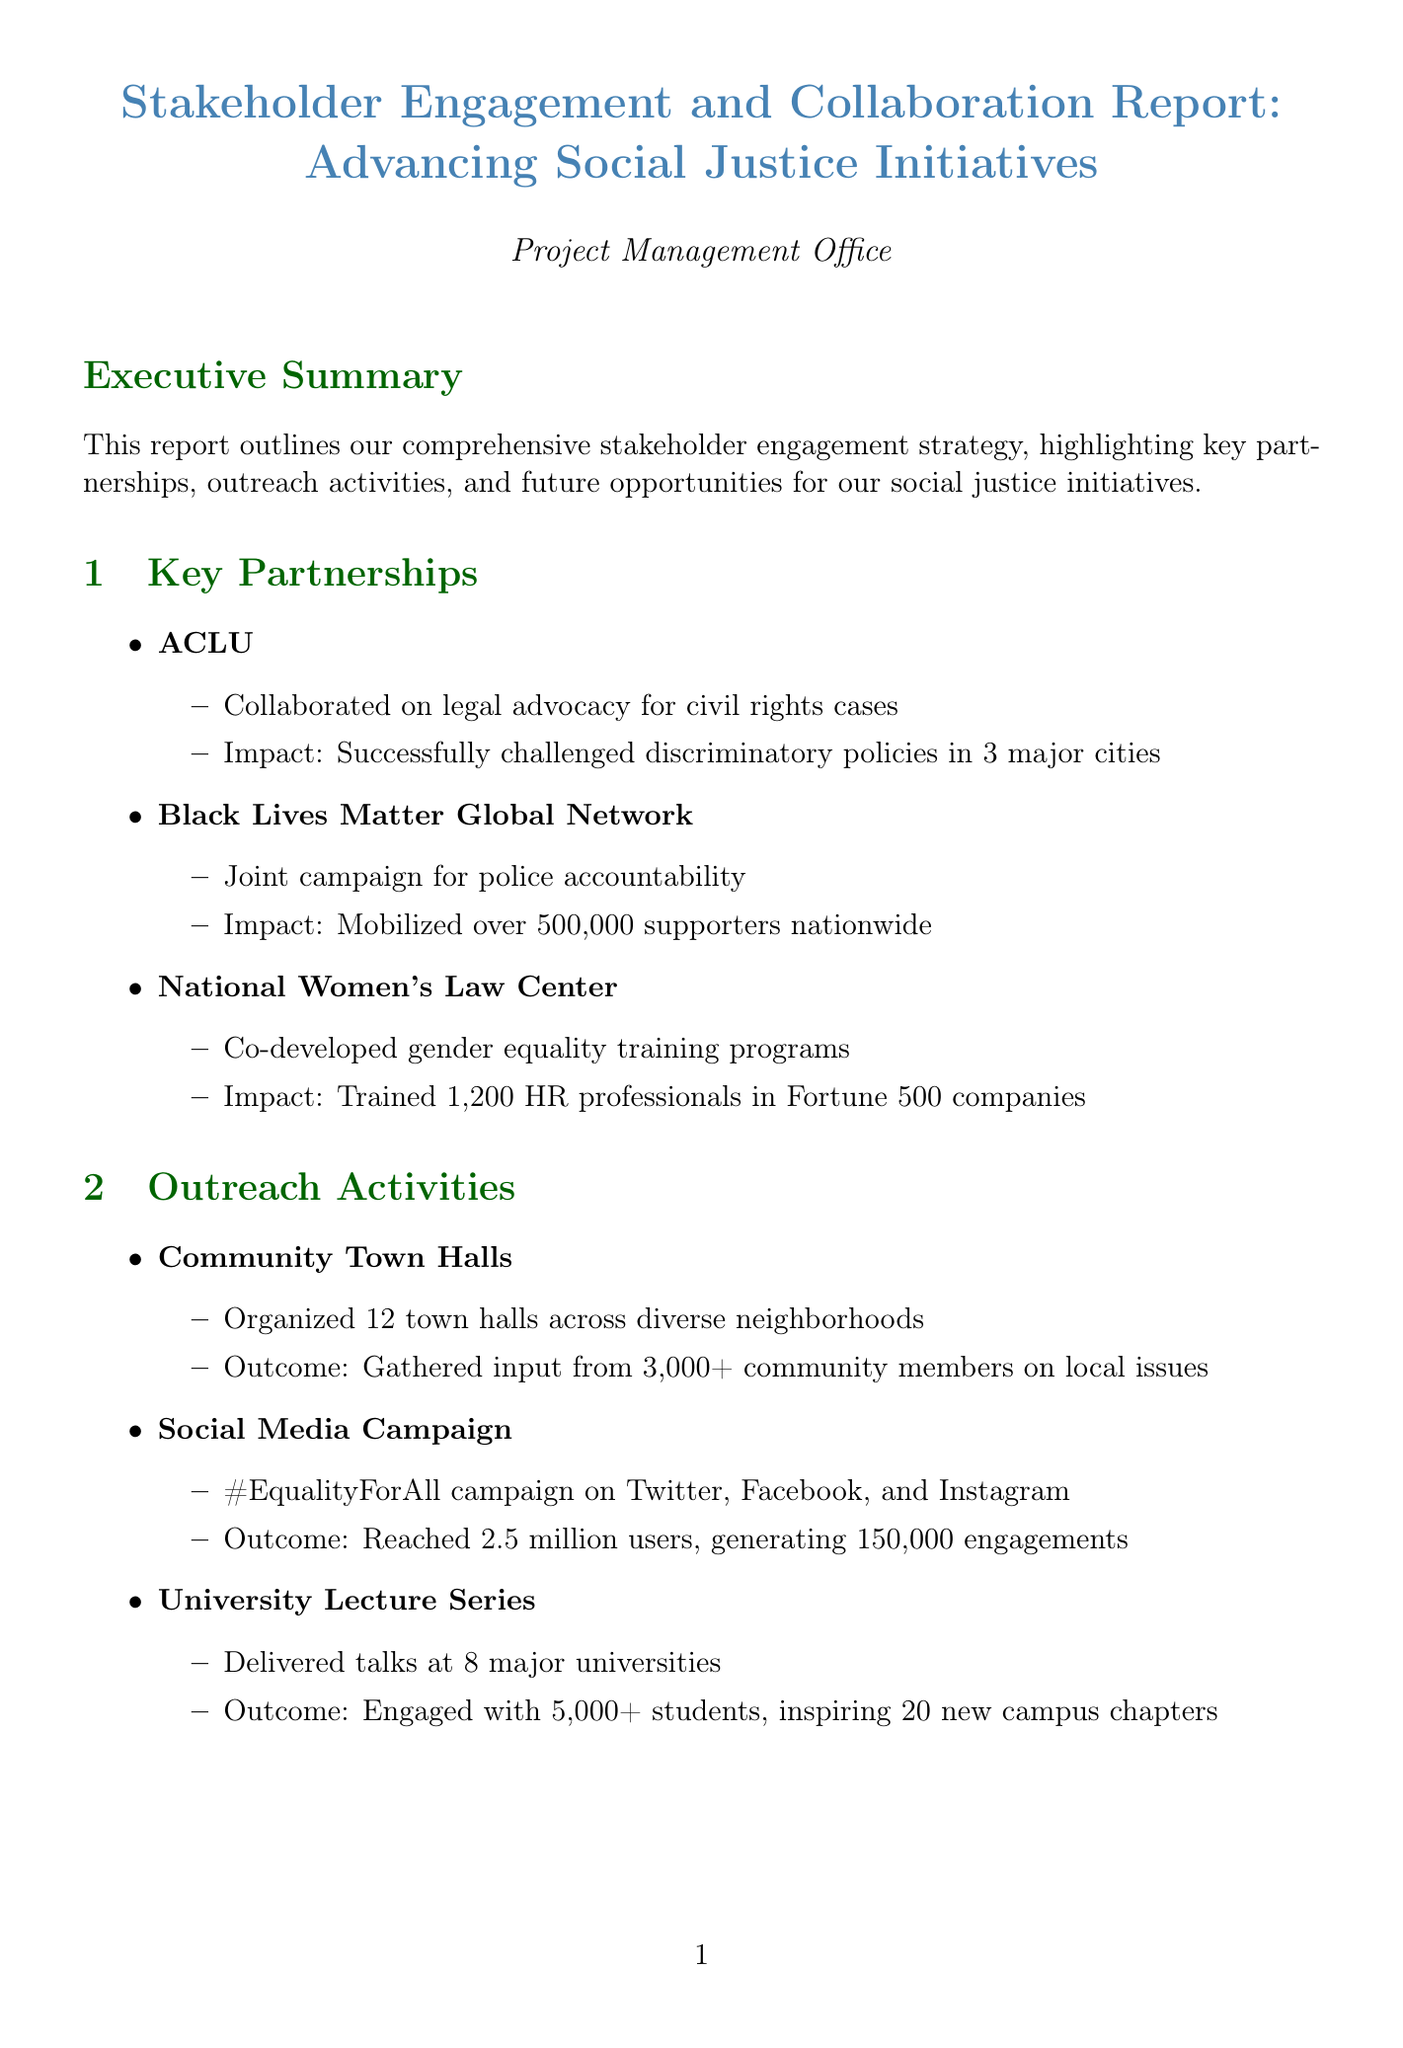what is the title of the report? The title of the report is stated at the beginning and provides an overview of its content.
Answer: Stakeholder Engagement and Collaboration Report: Advancing Social Justice Initiatives how many town halls were organized? The report details the outreach activities, including the number of town halls organized in diverse neighborhoods.
Answer: 12 who are the partners involved in key partnerships? The report lists each partner involved and their specific contributions to social justice initiatives.
Answer: ACLU, Black Lives Matter Global Network, National Women's Law Center what is one potential impact of the Corporate Diversity Initiative? The report outlines expected impacts from future opportunities, focusing on the Corporate Diversity Initiative.
Answer: Increase diversity in leadership positions by 30% within 5 years how many community members provided input during town halls? The outreach section of the report includes the number of community members who participated in town hall discussions.
Answer: 3,000+ what lesson learned mentions stakeholder interests? The challenges and lessons learned section emphasizes balancing interests as a key learning point.
Answer: Balancing diverse stakeholder interests while maintaining focus on core objectives how many universities were included in the lecture series? The outreach activities section of the report specifies the number of universities where lectures were delivered.
Answer: 8 which campaign reached 2.5 million users? The report highlights a social media campaign that garnered significant engagement from users.
Answer: #EqualityForAll campaign 